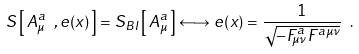Convert formula to latex. <formula><loc_0><loc_0><loc_500><loc_500>S \left [ \, A _ { \mu } ^ { a } \ , e ( x ) \, \right ] = S _ { B I } \left [ \, A _ { \mu } ^ { a } \, \right ] \longleftrightarrow e ( x ) = \frac { 1 } { \sqrt { - F _ { \mu \nu } ^ { a } F ^ { a \mu \nu } } } \ .</formula> 